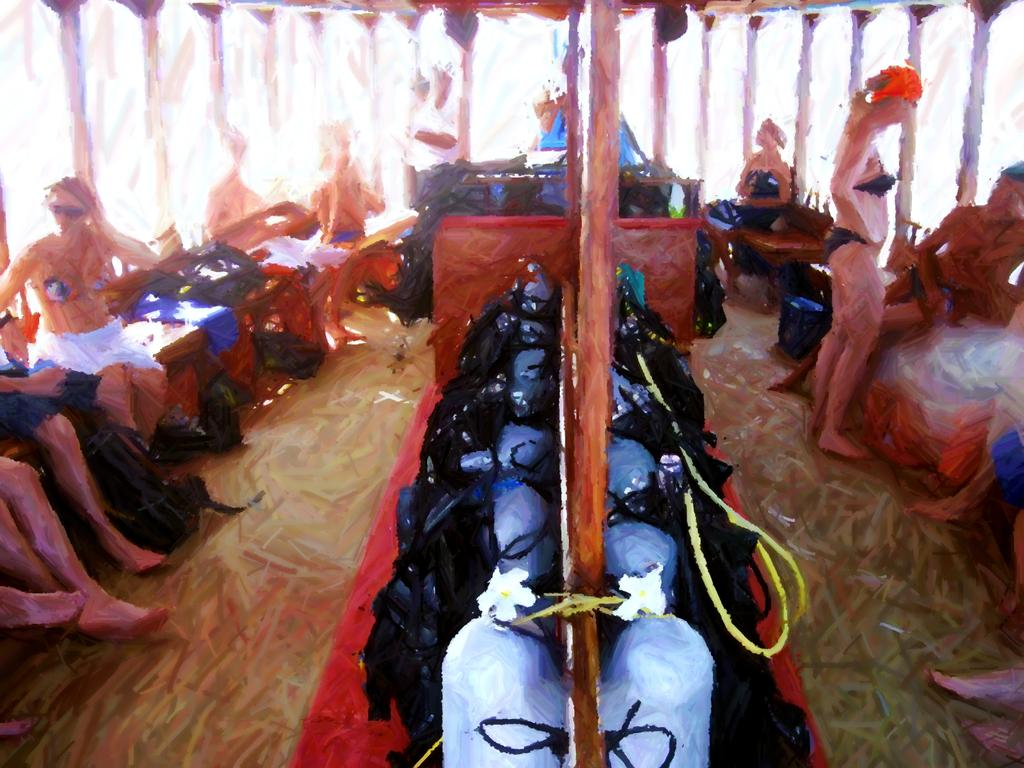What is the main subject of the image? There is a painting in the image. What can be seen in the painting? The painting contains many people and various objects. What advice is given by the person in the painting? There is no person in the painting who can give advice, as it is a painting and not a real-life scenario. 